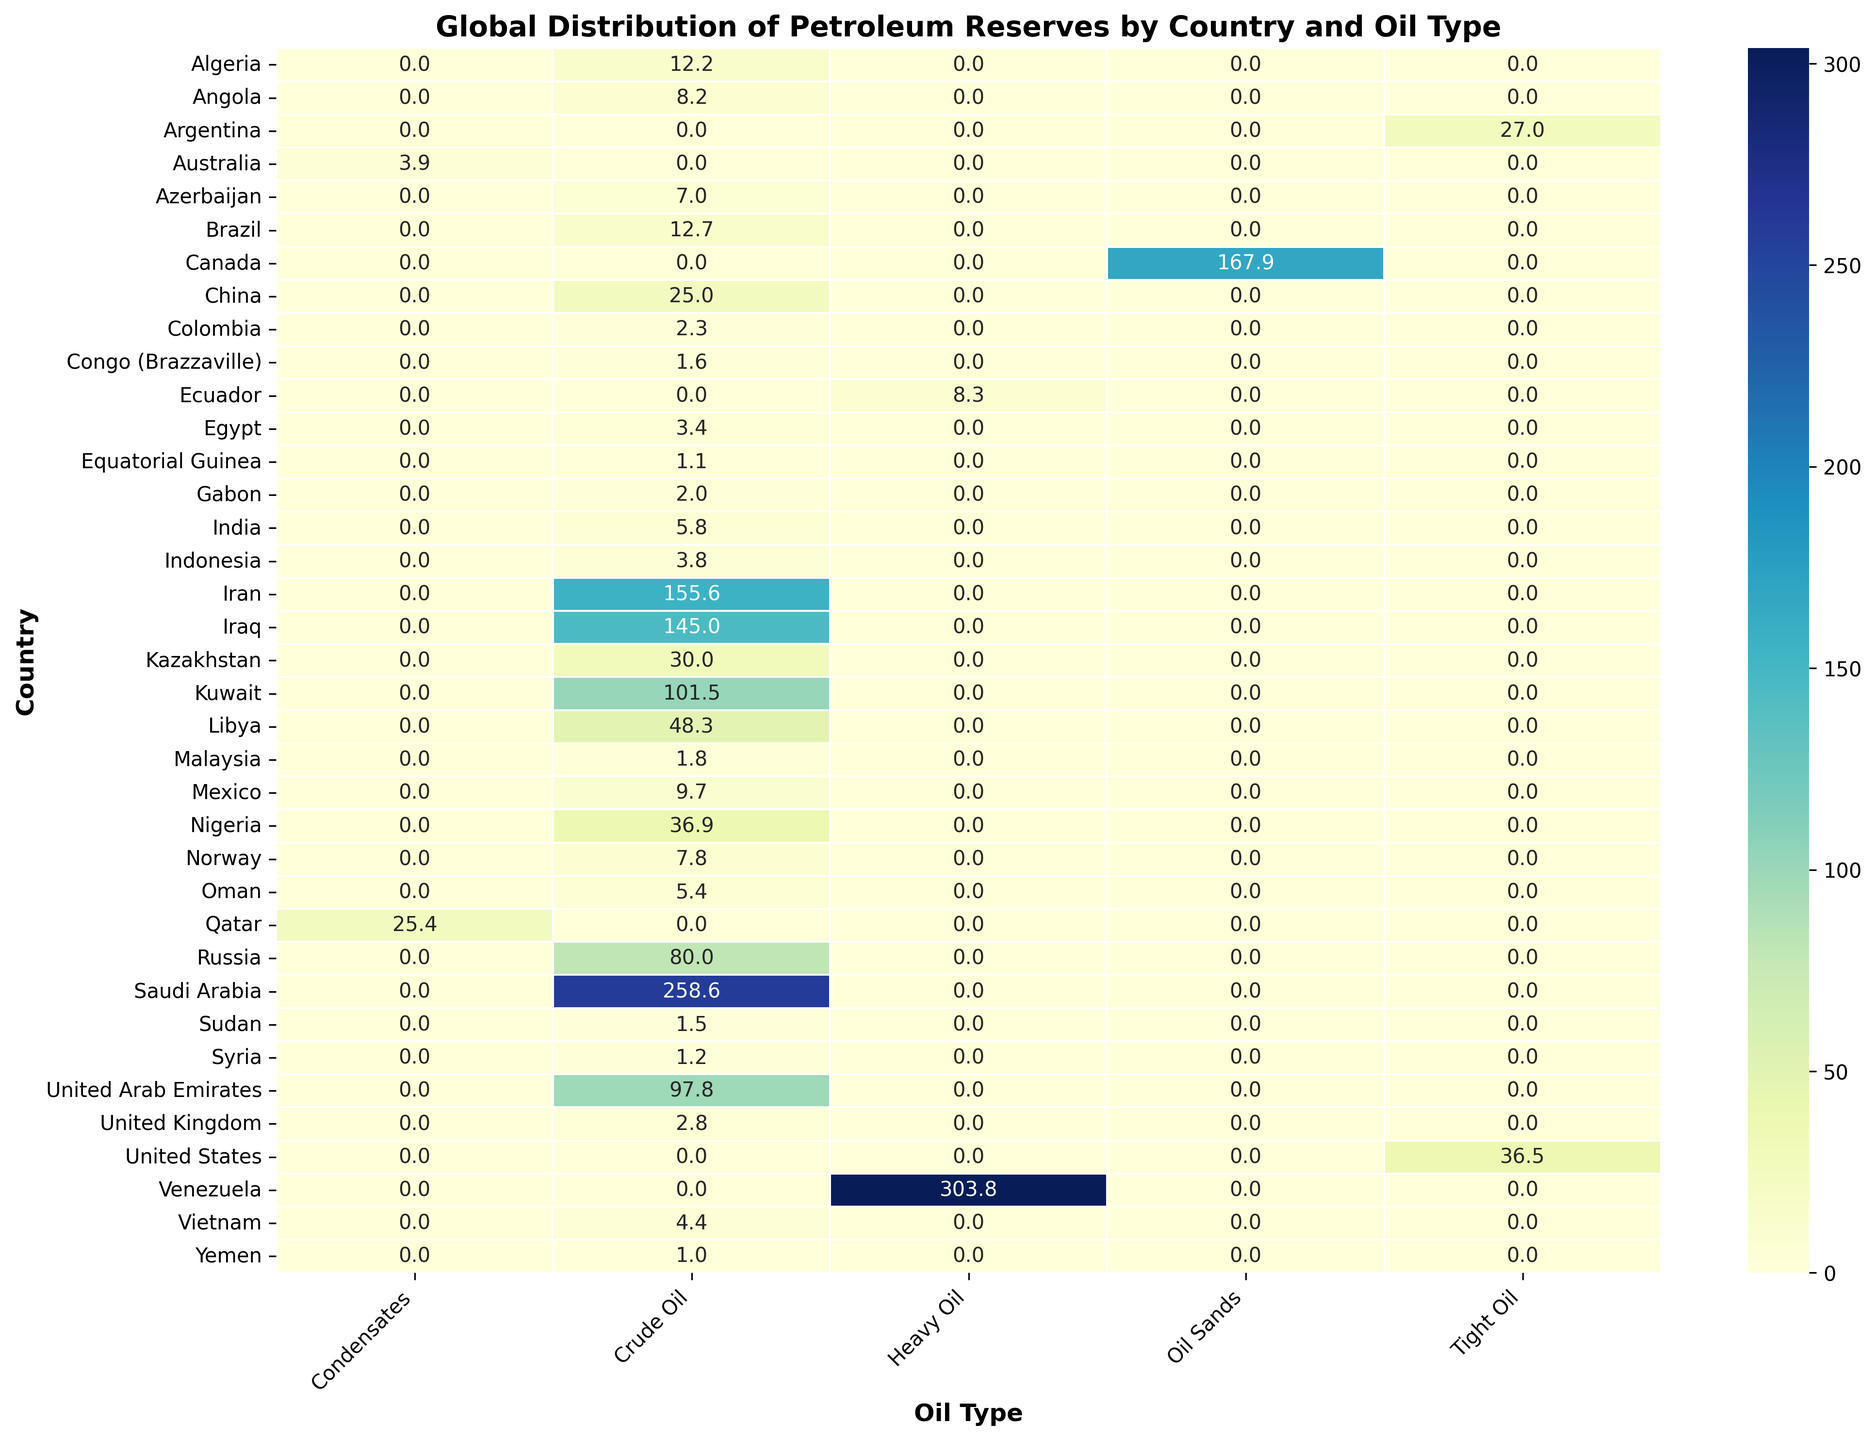Which country has the largest overall petroleum reserves and what is the value? By glancing at the heatmap, the country with the darkest color represents the highest reserves. For Venezuela, we see a reserve value of 303.8 billion barrels, which is the largest.
Answer: Venezuela, 303.8 billion barrels Which country has the highest crude oil reserves and what is their value? On the heatmap, looking specifically at the column for Crude Oil, Saudi Arabia has the darkest color, indicating the highest reserves, which is 258.6 billion barrels.
Answer: Saudi Arabia, 258.6 billion barrels How does the crude oil reserve in Saudi Arabia compare to that in Iraq? Compare the values in the Crude Oil column for Saudi Arabia and Iraq. Saudi Arabia has 258.6 billion barrels, while Iraq has 145.0 billion barrels. Saudi Arabia's reserves are higher.
Answer: Saudi Arabia's reserves are higher What is the total petroleum reserve for countries in the Middle East shown in the heatmap? Sum the reserves for Middle Eastern countries including Saudi Arabia (Crude Oil: 258.6), Iran (Crude Oil: 155.6), Iraq (Crude Oil: 145.0), Kuwait (Crude Oil: 101.5), UAE (Crude Oil: 97.8), Qatar (Condensates: 25.4), and Oman (Crude Oil: 5.4). The total is 789.3 billion barrels.
Answer: 789.3 billion barrels Which country has the highest reserves of tight oil and how do they compare to Canada's oil sands reserves? The highest value in the Tight Oil column is for Argentina (27.0 billion barrels), while the value for Oil Sands in Canada is 167.9 billion barrels. Canada’s reserves are significantly higher.
Answer: Canada’s reserves are significantly higher What is the average crude oil reserve per country in Africa shown in the heatmap? Identify African countries with crude oil reserves: Libya (48.3), Nigeria (36.9), Algeria (12.2), Angola (8.2), Egypt (3.4), Gabon (2.0), Sudan (1.5), Equatorial Guinea (1.1), and Congo (Brazzaville, 1.6). Average is (48.3 + 36.9 + 12.2 + 8.2 + 3.4 + 2.0 + 1.5 + 1.1 + 1.6) / 9 ≈ 12.8 billion barrels.
Answer: 12.8 billion barrels How does the total reserve of Venezuela compare with the combined reserve of Saudi Arabia and Canada? Sum the reserves of Saudi Arabia (258.6 billion barrels) and Canada (167.9 billion barrels), which gives 426.5 billion barrels. Venezuela alone has 303.8 billion barrels, which is less than the combined value of Saudi Arabia and Canada.
Answer: Venezuela has less What are the top three countries with the highest reserves of a single oil type? The heatmap highlights the highest reserves: Venezuela (Heavy Oil: 303.8), Saudi Arabia (Crude Oil: 258.6), and Canada (Oil Sands: 167.9). These are the top three.
Answer: Venezuela, Saudi Arabia, Canada Which oil type reserves are most evenly distributed among countries? By observing the color intensity in each oil type column, Condensates seem to have more uniform colors across Qatar and Australia, indicating a more even distribution compared to others with stark differences.
Answer: Condensates What is the total reserve of crude oil in South America shown in the heatmap? Sum the crude oil reserves for South American countries: Brazil (12.7), Ecuador (8.3), Colombia (2.3), Venezuela (303.8). Exclude numerical values not fitting crude oil from Venezuela. The total crude oil reserves are (12.7 + 8.3 + 2.3) = 23.3 billion barrels.
Answer: 23.3 billion barrels 